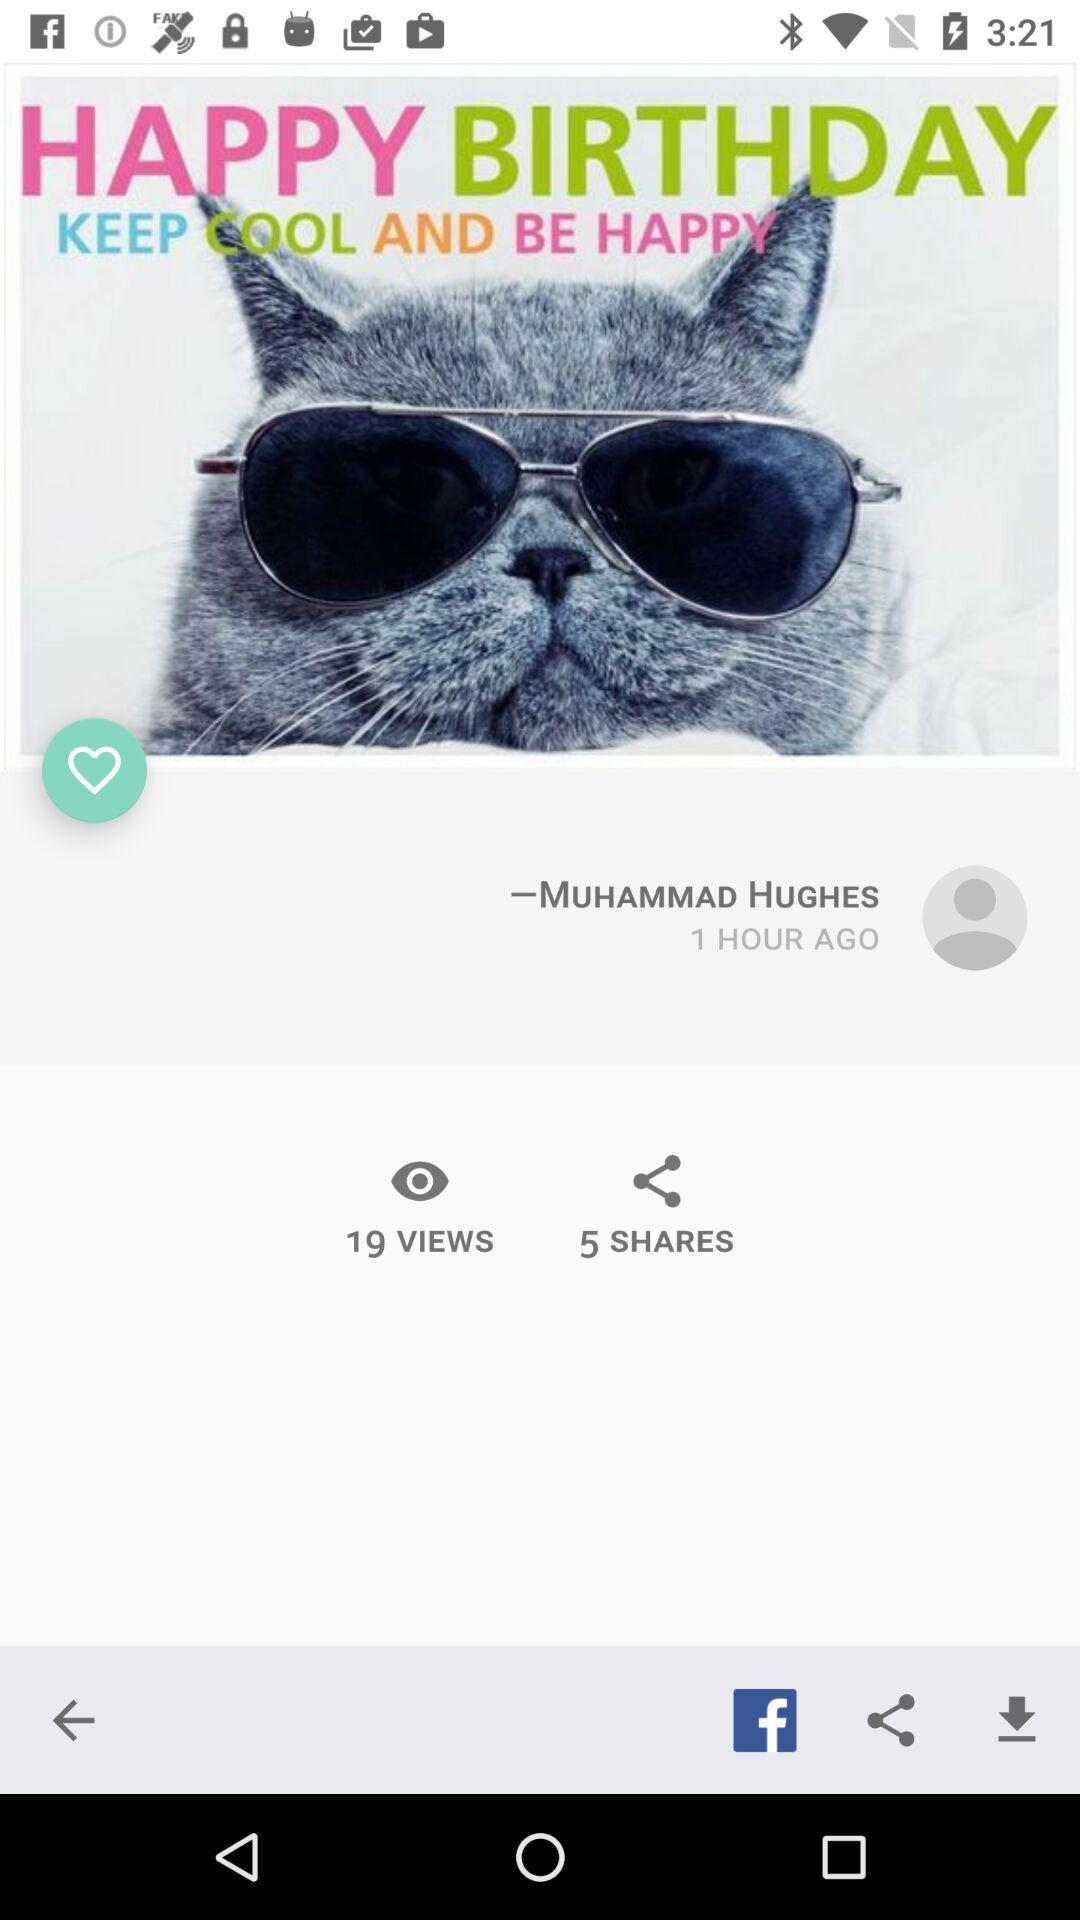What is the user name? The user name is "-MUHAMMAD HUGHES". 